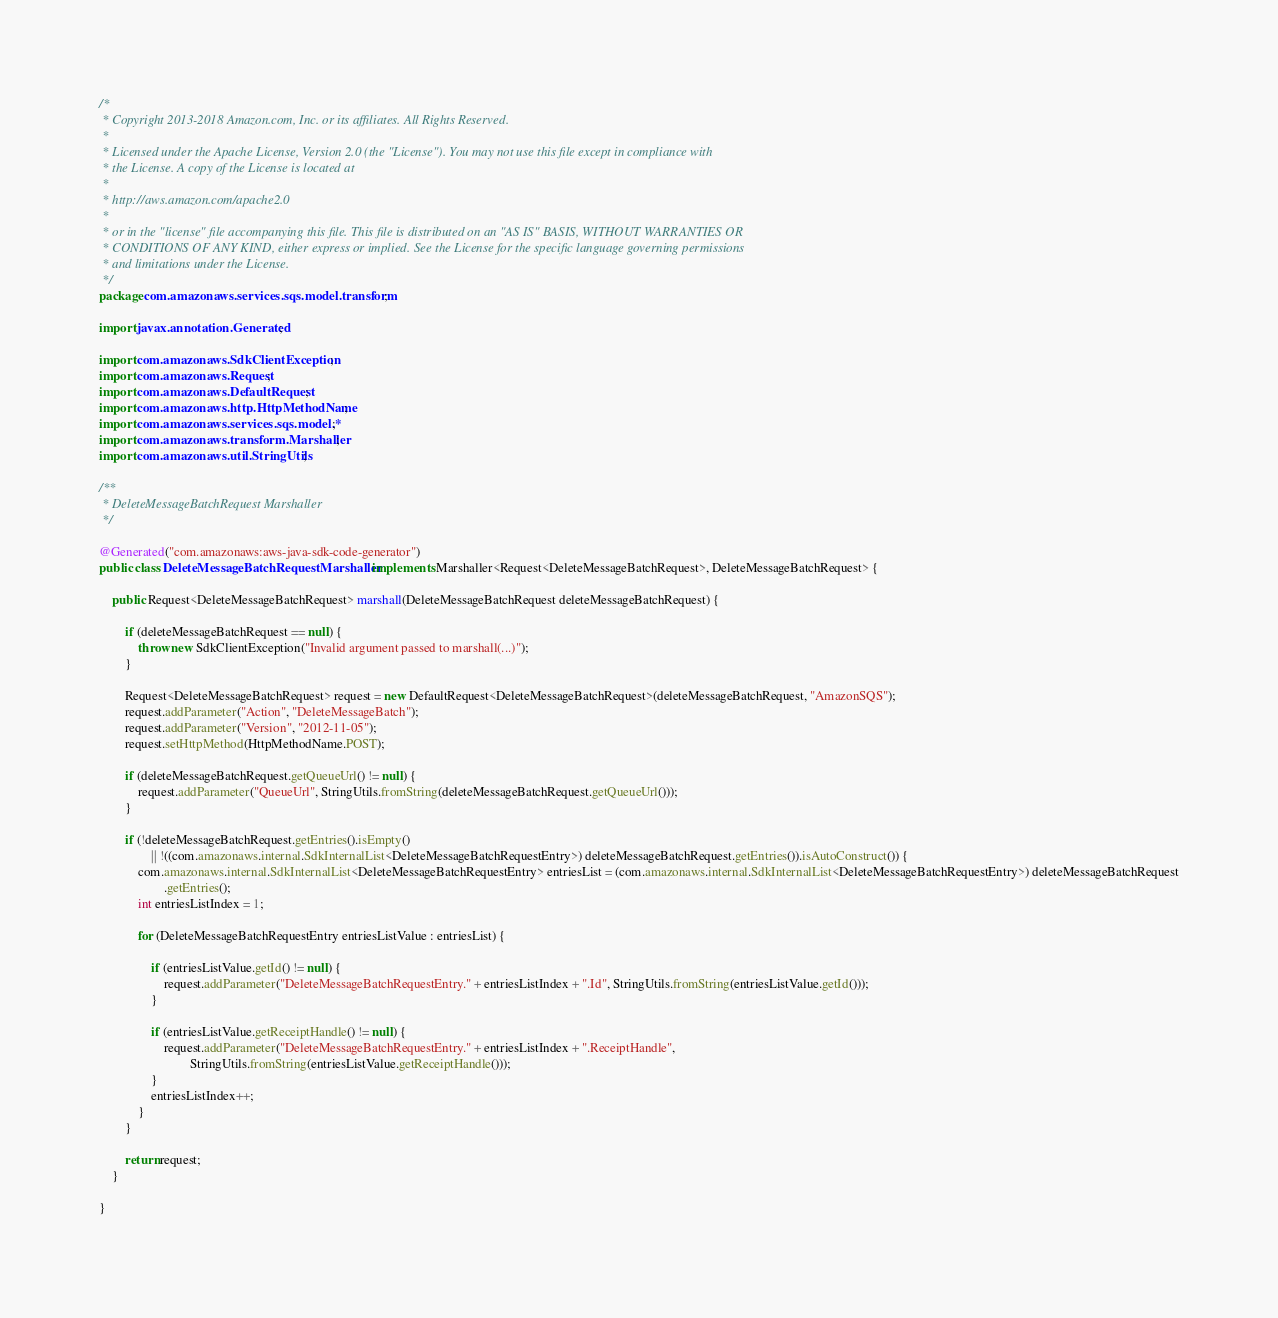<code> <loc_0><loc_0><loc_500><loc_500><_Java_>/*
 * Copyright 2013-2018 Amazon.com, Inc. or its affiliates. All Rights Reserved.
 * 
 * Licensed under the Apache License, Version 2.0 (the "License"). You may not use this file except in compliance with
 * the License. A copy of the License is located at
 * 
 * http://aws.amazon.com/apache2.0
 * 
 * or in the "license" file accompanying this file. This file is distributed on an "AS IS" BASIS, WITHOUT WARRANTIES OR
 * CONDITIONS OF ANY KIND, either express or implied. See the License for the specific language governing permissions
 * and limitations under the License.
 */
package com.amazonaws.services.sqs.model.transform;

import javax.annotation.Generated;

import com.amazonaws.SdkClientException;
import com.amazonaws.Request;
import com.amazonaws.DefaultRequest;
import com.amazonaws.http.HttpMethodName;
import com.amazonaws.services.sqs.model.*;
import com.amazonaws.transform.Marshaller;
import com.amazonaws.util.StringUtils;

/**
 * DeleteMessageBatchRequest Marshaller
 */

@Generated("com.amazonaws:aws-java-sdk-code-generator")
public class DeleteMessageBatchRequestMarshaller implements Marshaller<Request<DeleteMessageBatchRequest>, DeleteMessageBatchRequest> {

    public Request<DeleteMessageBatchRequest> marshall(DeleteMessageBatchRequest deleteMessageBatchRequest) {

        if (deleteMessageBatchRequest == null) {
            throw new SdkClientException("Invalid argument passed to marshall(...)");
        }

        Request<DeleteMessageBatchRequest> request = new DefaultRequest<DeleteMessageBatchRequest>(deleteMessageBatchRequest, "AmazonSQS");
        request.addParameter("Action", "DeleteMessageBatch");
        request.addParameter("Version", "2012-11-05");
        request.setHttpMethod(HttpMethodName.POST);

        if (deleteMessageBatchRequest.getQueueUrl() != null) {
            request.addParameter("QueueUrl", StringUtils.fromString(deleteMessageBatchRequest.getQueueUrl()));
        }

        if (!deleteMessageBatchRequest.getEntries().isEmpty()
                || !((com.amazonaws.internal.SdkInternalList<DeleteMessageBatchRequestEntry>) deleteMessageBatchRequest.getEntries()).isAutoConstruct()) {
            com.amazonaws.internal.SdkInternalList<DeleteMessageBatchRequestEntry> entriesList = (com.amazonaws.internal.SdkInternalList<DeleteMessageBatchRequestEntry>) deleteMessageBatchRequest
                    .getEntries();
            int entriesListIndex = 1;

            for (DeleteMessageBatchRequestEntry entriesListValue : entriesList) {

                if (entriesListValue.getId() != null) {
                    request.addParameter("DeleteMessageBatchRequestEntry." + entriesListIndex + ".Id", StringUtils.fromString(entriesListValue.getId()));
                }

                if (entriesListValue.getReceiptHandle() != null) {
                    request.addParameter("DeleteMessageBatchRequestEntry." + entriesListIndex + ".ReceiptHandle",
                            StringUtils.fromString(entriesListValue.getReceiptHandle()));
                }
                entriesListIndex++;
            }
        }

        return request;
    }

}
</code> 